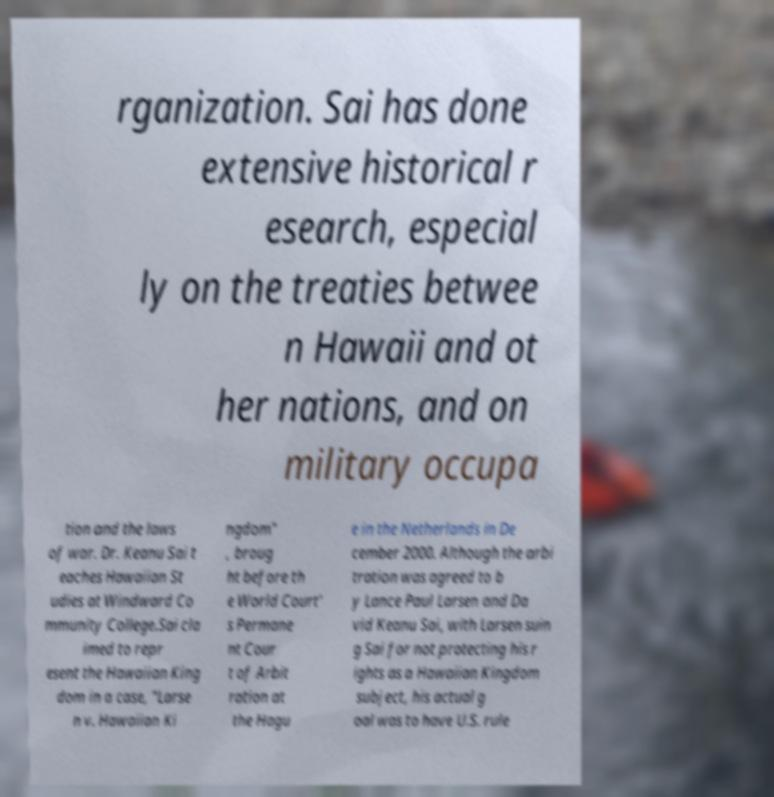For documentation purposes, I need the text within this image transcribed. Could you provide that? rganization. Sai has done extensive historical r esearch, especial ly on the treaties betwee n Hawaii and ot her nations, and on military occupa tion and the laws of war. Dr. Keanu Sai t eaches Hawaiian St udies at Windward Co mmunity College.Sai cla imed to repr esent the Hawaiian King dom in a case, "Larse n v. Hawaiian Ki ngdom" , broug ht before th e World Court' s Permane nt Cour t of Arbit ration at the Hagu e in the Netherlands in De cember 2000. Although the arbi tration was agreed to b y Lance Paul Larsen and Da vid Keanu Sai, with Larsen suin g Sai for not protecting his r ights as a Hawaiian Kingdom subject, his actual g oal was to have U.S. rule 